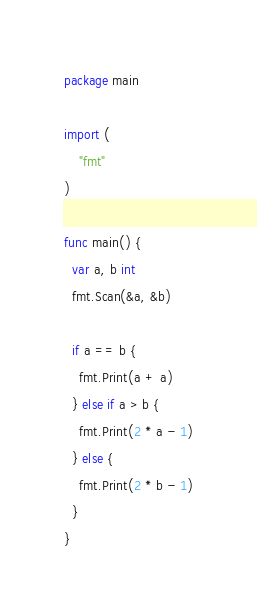<code> <loc_0><loc_0><loc_500><loc_500><_Go_>package main

import (
    "fmt"
)

func main() {
  var a, b int
  fmt.Scan(&a, &b)
  
  if a == b {
    fmt.Print(a + a)
  } else if a > b {
    fmt.Print(2 * a - 1)
  } else {
    fmt.Print(2 * b - 1)
  }
}</code> 